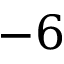<formula> <loc_0><loc_0><loc_500><loc_500>- 6</formula> 